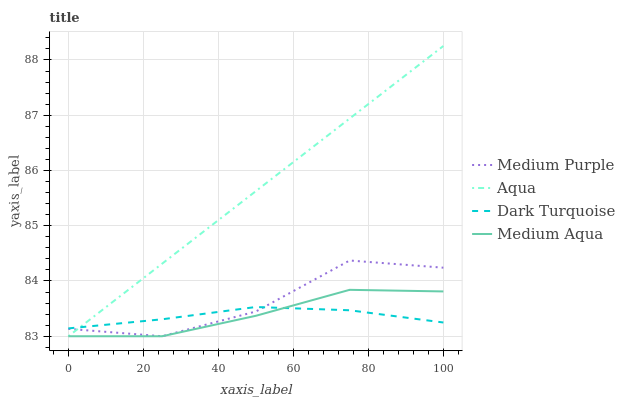Does Dark Turquoise have the minimum area under the curve?
Answer yes or no. Yes. Does Aqua have the maximum area under the curve?
Answer yes or no. Yes. Does Medium Aqua have the minimum area under the curve?
Answer yes or no. No. Does Medium Aqua have the maximum area under the curve?
Answer yes or no. No. Is Aqua the smoothest?
Answer yes or no. Yes. Is Medium Purple the roughest?
Answer yes or no. Yes. Is Dark Turquoise the smoothest?
Answer yes or no. No. Is Dark Turquoise the roughest?
Answer yes or no. No. Does Medium Purple have the lowest value?
Answer yes or no. Yes. Does Dark Turquoise have the lowest value?
Answer yes or no. No. Does Aqua have the highest value?
Answer yes or no. Yes. Does Medium Aqua have the highest value?
Answer yes or no. No. Does Medium Purple intersect Dark Turquoise?
Answer yes or no. Yes. Is Medium Purple less than Dark Turquoise?
Answer yes or no. No. Is Medium Purple greater than Dark Turquoise?
Answer yes or no. No. 